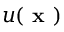<formula> <loc_0><loc_0><loc_500><loc_500>u ( x )</formula> 